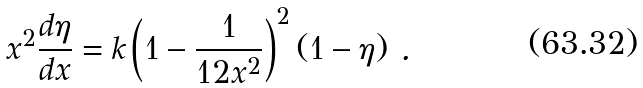<formula> <loc_0><loc_0><loc_500><loc_500>x ^ { 2 } \frac { d \eta } { d x } = k \left ( 1 - \frac { 1 } { 1 2 x ^ { 2 } } \right ) ^ { 2 } ( 1 - \eta ) \ .</formula> 